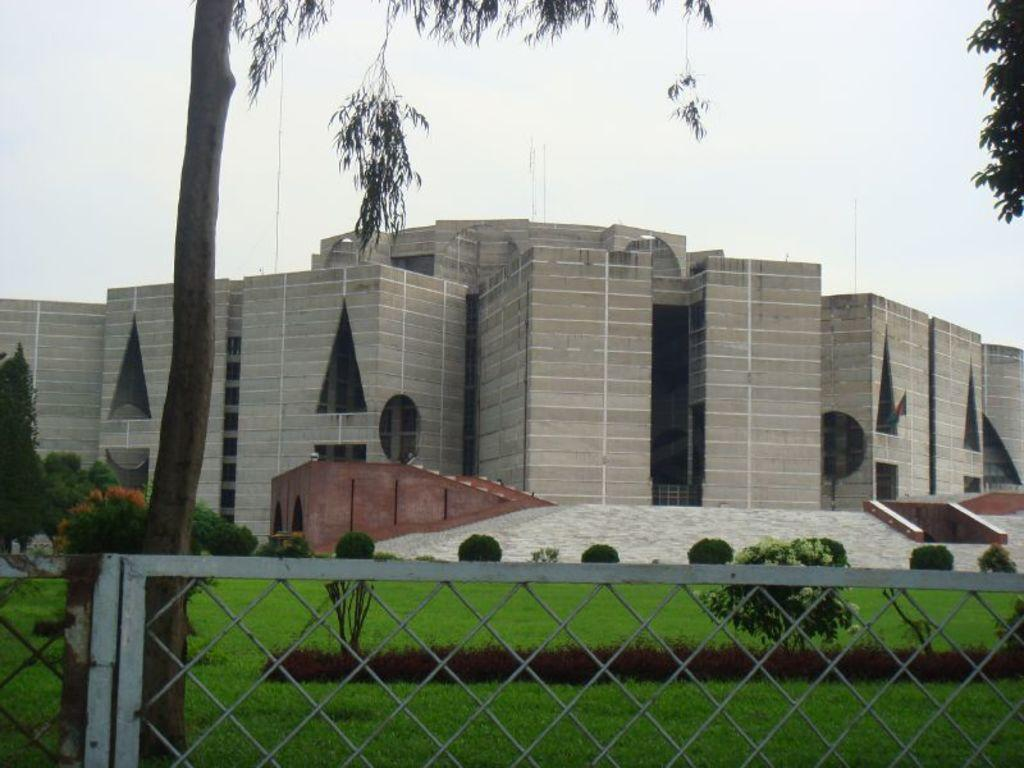What type of barrier can be seen in the image? There is a fence in the image. What type of vegetation is present in the image? There are plants, grass, and trees in the image. What is visible in the background of the image? There is a building and the sky visible in the background of the image. How many eggs are being used to build the fence in the image? There are no eggs present in the image, and eggs are not used to build fences. Is there a camp visible in the image? There is no camp present in the image. 